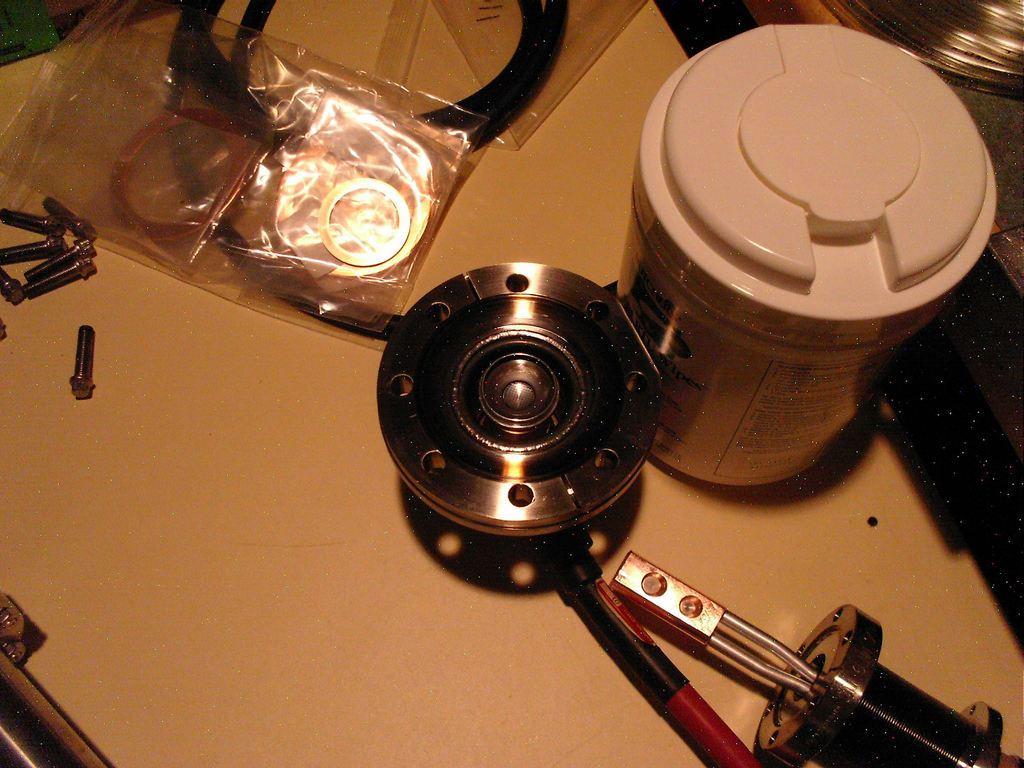Describe this image in one or two sentences. In this image there is a table and we can see nuts, cover, tin, wire and some objects placed on the table. 